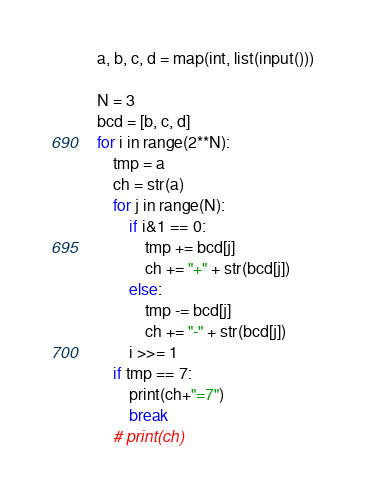Convert code to text. <code><loc_0><loc_0><loc_500><loc_500><_Python_>a, b, c, d = map(int, list(input()))

N = 3
bcd = [b, c, d]
for i in range(2**N):
    tmp = a
    ch = str(a)
    for j in range(N):
        if i&1 == 0:
            tmp += bcd[j]
            ch += "+" + str(bcd[j])
        else:
            tmp -= bcd[j]
            ch += "-" + str(bcd[j])
        i >>= 1
    if tmp == 7:
        print(ch+"=7")
        break
    # print(ch)
</code> 